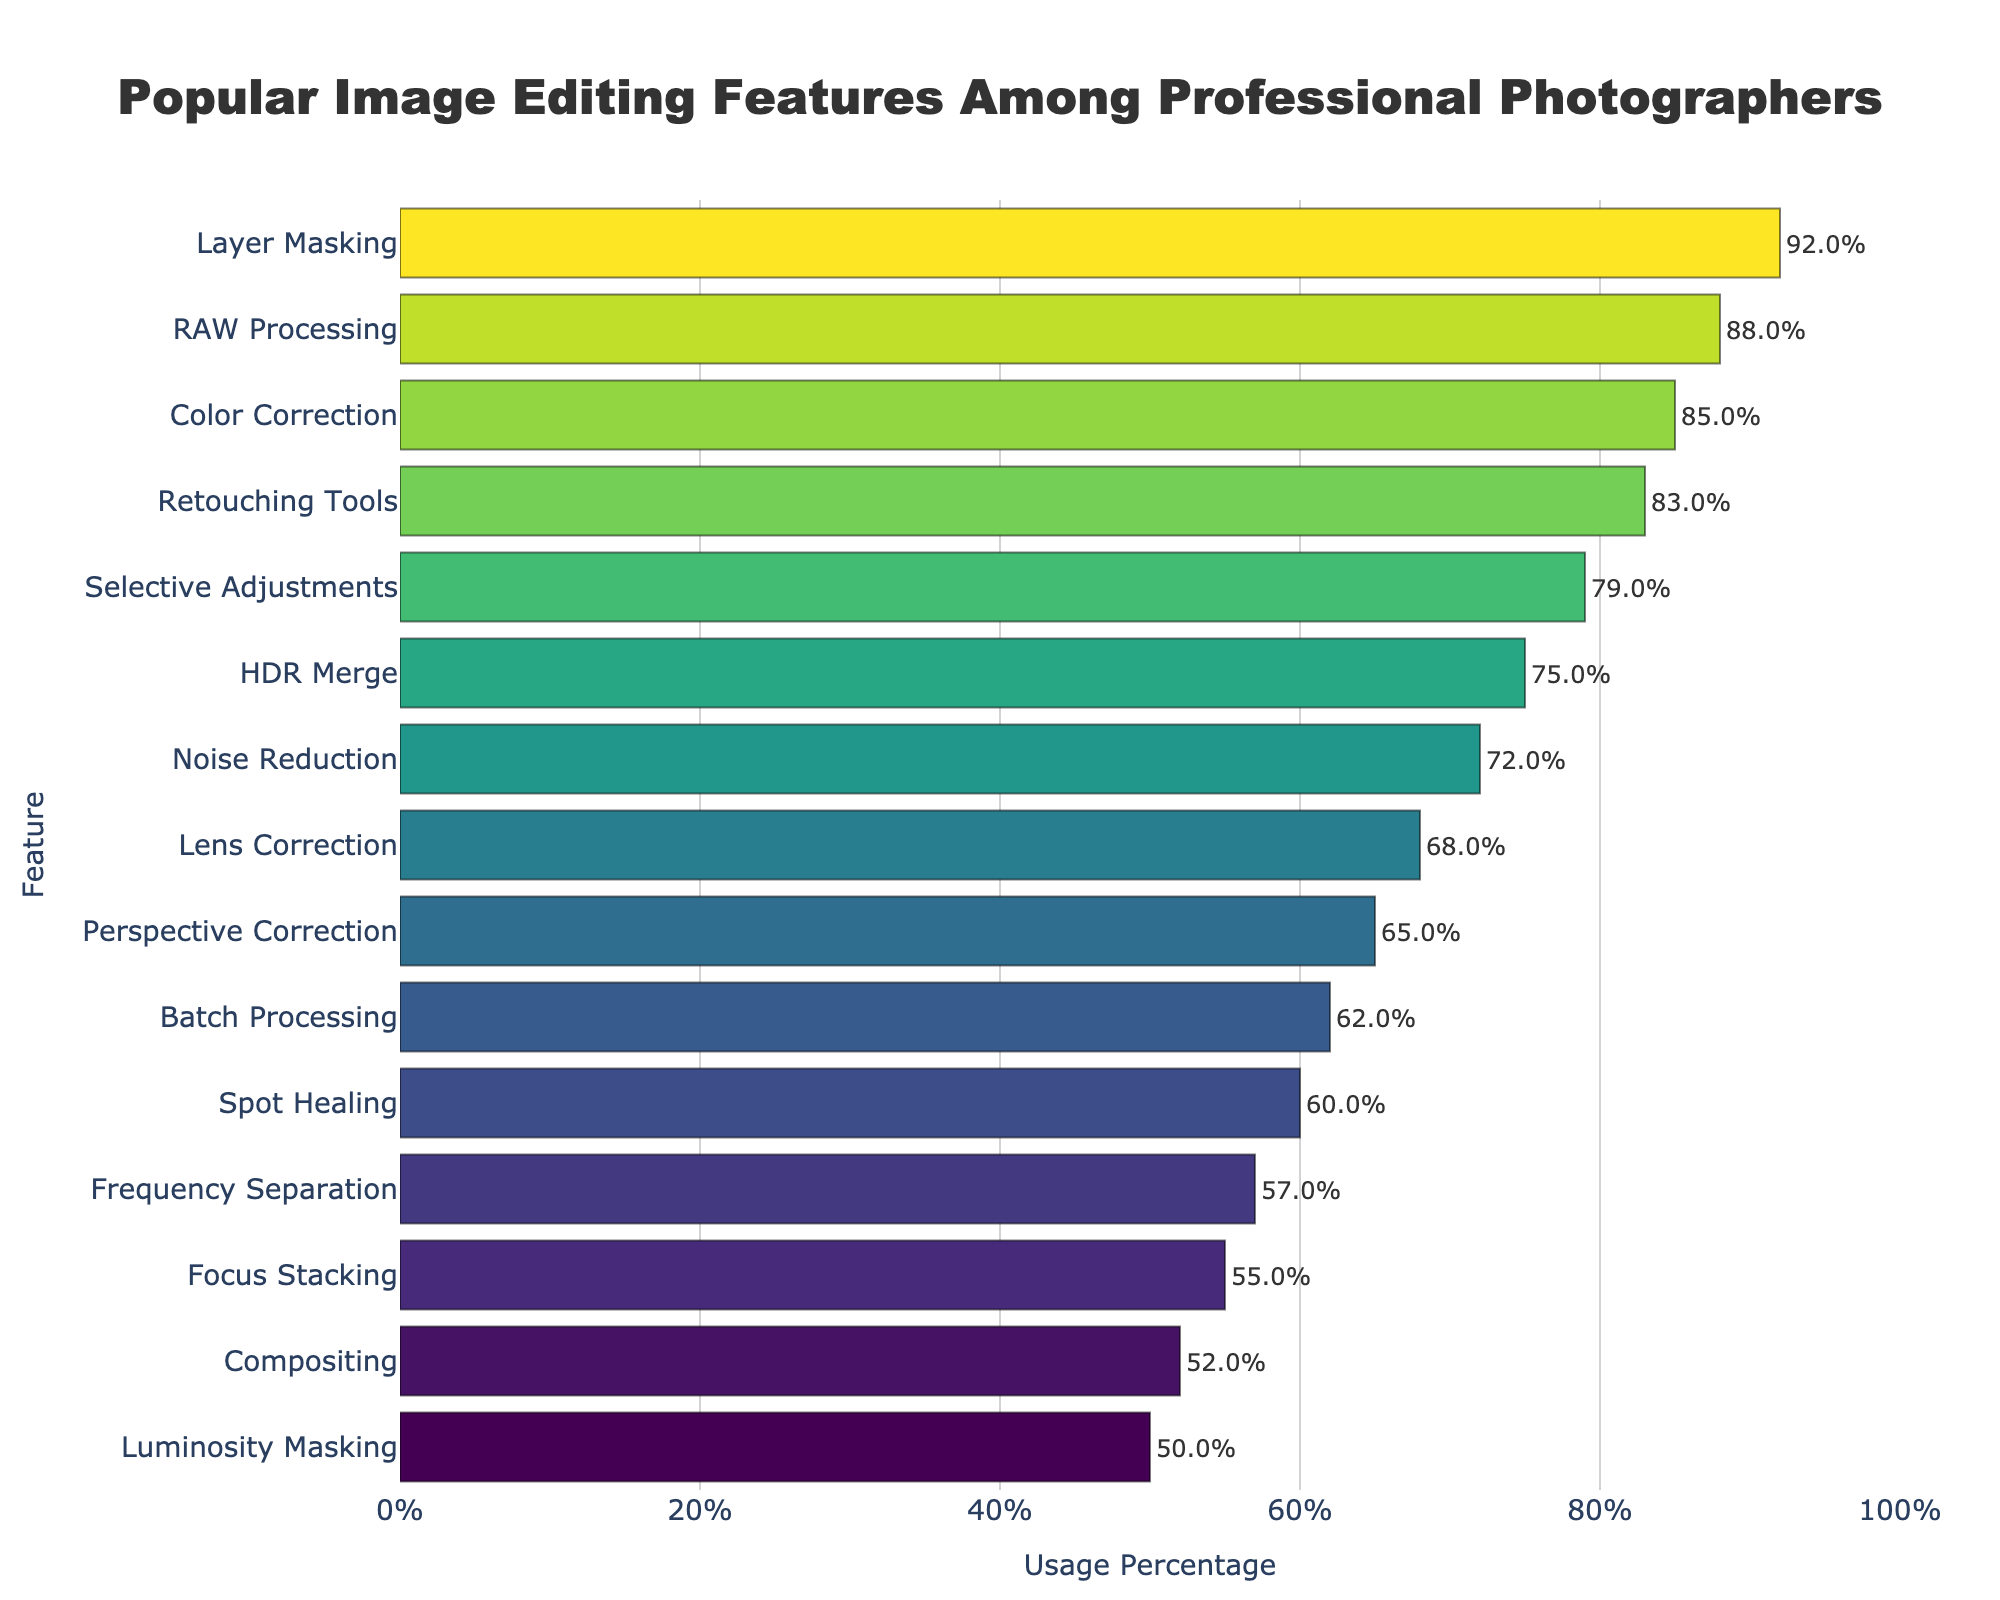Which feature has the highest usage percentage? The bar chart shows the length of each bar corresponding to the usage percentage of different features. The longest bar corresponds to Layer Masking with 92%.
Answer: Layer Masking What is the usage percentage difference between Layer Masking and HDR Merge? Refer to the labels for Layer Masking (92%) and HDR Merge (75%) on the chart, then calculate the difference: 92% - 75% = 17%.
Answer: 17% Which features have a usage percentage above 80%? Look at the bars whose values are above 80%: Layer Masking (92%), RAW Processing (88%), Color Correction (85%), and Retouching Tools (83%).
Answer: Layer Masking, RAW Processing, Color Correction, Retouching Tools How many features have a usage percentage between 60% and 70% inclusive? Identify the bars within the 60%-70% range: Lens Correction (68%), Perspective Correction (65%), Batch Processing (62%), and Spot Healing (60%). Count them: 4 features.
Answer: 4 What is the average usage percentage of the top 3 features? Calculate the average of the percentages for the top 3 features: (92% + 88% + 85%) / 3 = 88.33%.
Answer: 88.33% Which feature has a lower usage percentage, Frequency Separation or Focus Stacking? Compare the values for Frequency Separation (57%) and Focus Stacking (55%). Focus Stacking has a lower percentage.
Answer: Focus Stacking What is the range of usage percentages for all the features? Subtract the smallest percentage (Luminosity Masking, 50%) from the largest percentage (Layer Masking, 92%): 92% - 50% = 42%.
Answer: 42% What is the median usage percentage of all features? List all usage percentages and find the middle value. The ordered percentages are: [50, 52, 55, 57, 60, 62, 65, 68, 72, 75, 79, 83, 85, 88, 92]. The middle value (8th) is 68%.
Answer: 68% Which feature shows a greater usage percentage, Noise Reduction or Selective Adjustments? Compare the values: Noise Reduction (72%) and Selective Adjustments (79%). Selective Adjustments has a greater percentage.
Answer: Selective Adjustments 